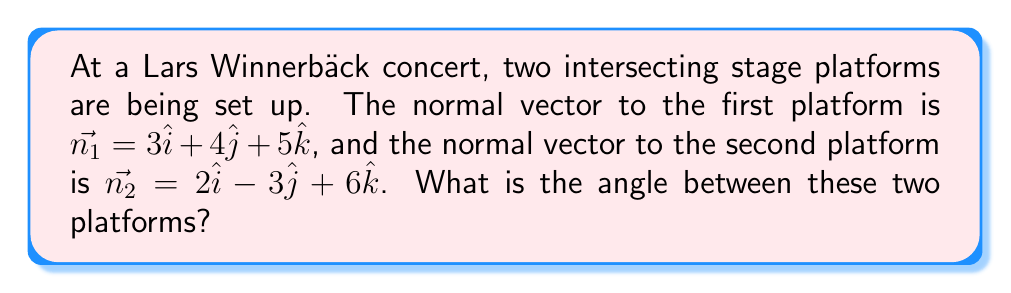Help me with this question. To find the angle between two intersecting planes, we can use the dot product of their normal vectors. The formula for the angle $\theta$ between two planes with normal vectors $\vec{n_1}$ and $\vec{n_2}$ is:

$$\cos \theta = \frac{|\vec{n_1} \cdot \vec{n_2}|}{|\vec{n_1}||\vec{n_2}|}$$

Let's solve this step by step:

1) First, calculate the dot product $\vec{n_1} \cdot \vec{n_2}$:
   $$\vec{n_1} \cdot \vec{n_2} = (3)(2) + (4)(-3) + (5)(6) = 6 - 12 + 30 = 24$$

2) Next, calculate the magnitudes of $\vec{n_1}$ and $\vec{n_2}$:
   $$|\vec{n_1}| = \sqrt{3^2 + 4^2 + 5^2} = \sqrt{9 + 16 + 25} = \sqrt{50}$$
   $$|\vec{n_2}| = \sqrt{2^2 + (-3)^2 + 6^2} = \sqrt{4 + 9 + 36} = \sqrt{49} = 7$$

3) Now, substitute these values into the formula:
   $$\cos \theta = \frac{|24|}{\sqrt{50} \cdot 7} = \frac{24}{\sqrt{50} \cdot 7}$$

4) Simplify:
   $$\cos \theta = \frac{24}{7\sqrt{50}} = \frac{24}{7\sqrt{2} \cdot 5} = \frac{24}{7\sqrt{2} \cdot \sqrt{25}} = \frac{24}{35\sqrt{2}}$$

5) To get $\theta$, we need to take the inverse cosine (arccos) of both sides:
   $$\theta = \arccos(\frac{24}{35\sqrt{2}})$$

6) Using a calculator, we can evaluate this to get the angle in radians, then convert to degrees:
   $$\theta \approx 1.0996 \text{ radians} \approx 63.0° \text{ (to 1 decimal place)}$$
Answer: The angle between the two stage platforms is approximately $63.0°$. 